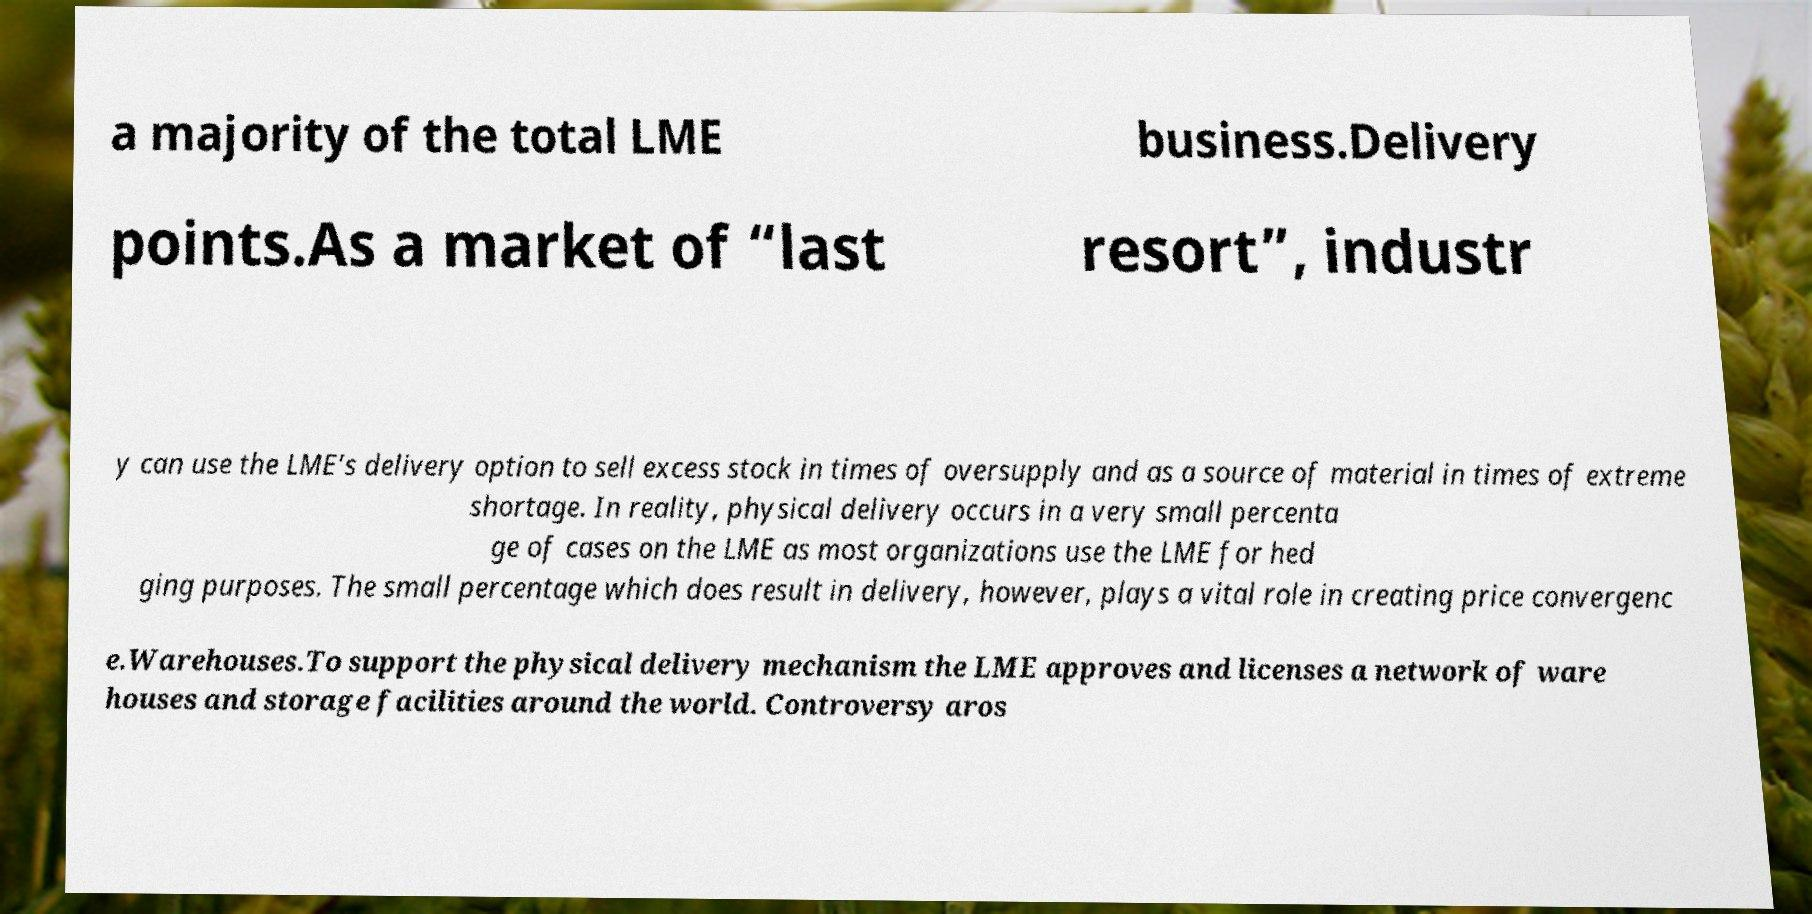Can you accurately transcribe the text from the provided image for me? a majority of the total LME business.Delivery points.As a market of “last resort”, industr y can use the LME’s delivery option to sell excess stock in times of oversupply and as a source of material in times of extreme shortage. In reality, physical delivery occurs in a very small percenta ge of cases on the LME as most organizations use the LME for hed ging purposes. The small percentage which does result in delivery, however, plays a vital role in creating price convergenc e.Warehouses.To support the physical delivery mechanism the LME approves and licenses a network of ware houses and storage facilities around the world. Controversy aros 